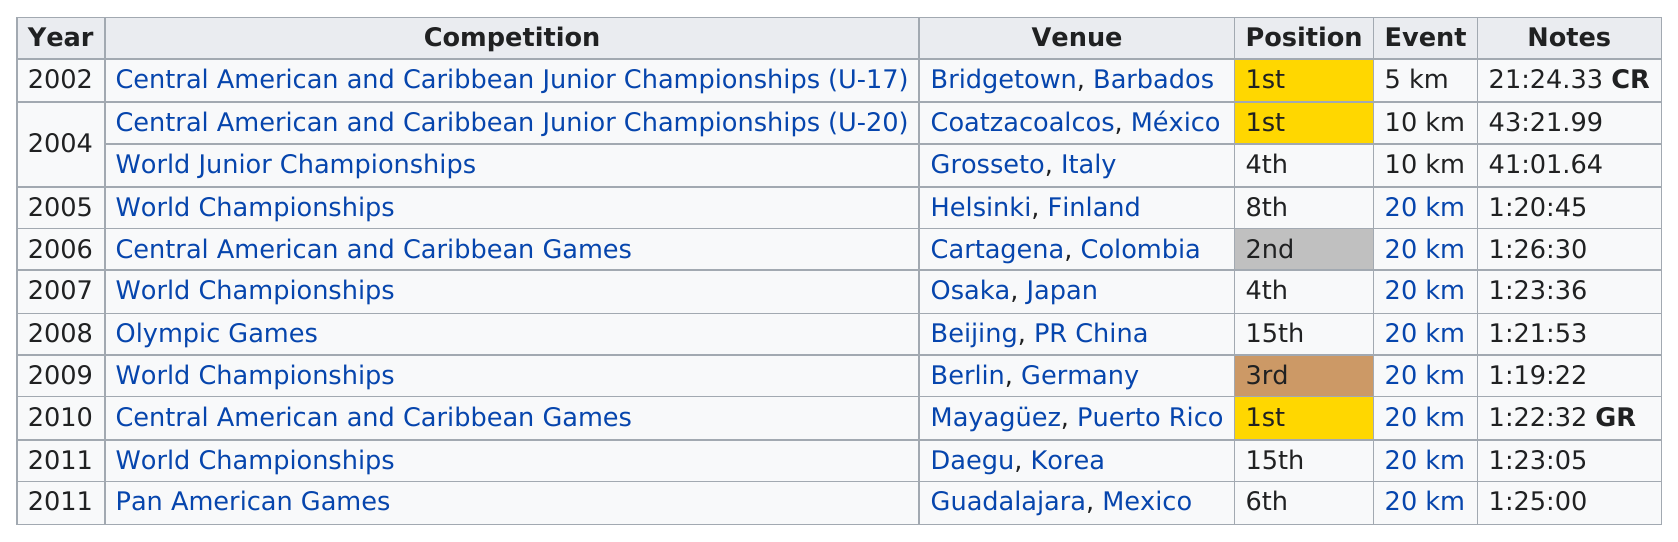Specify some key components in this picture. The event held in Helsinki, Finland was approximately 20 kilometers in length. They participated in the World Championships four times. Since 2008, the number of times the team placed first is 1. The 5 km event did not take place in any other year apart from 2002. In 2010, they received first place for the last time. 